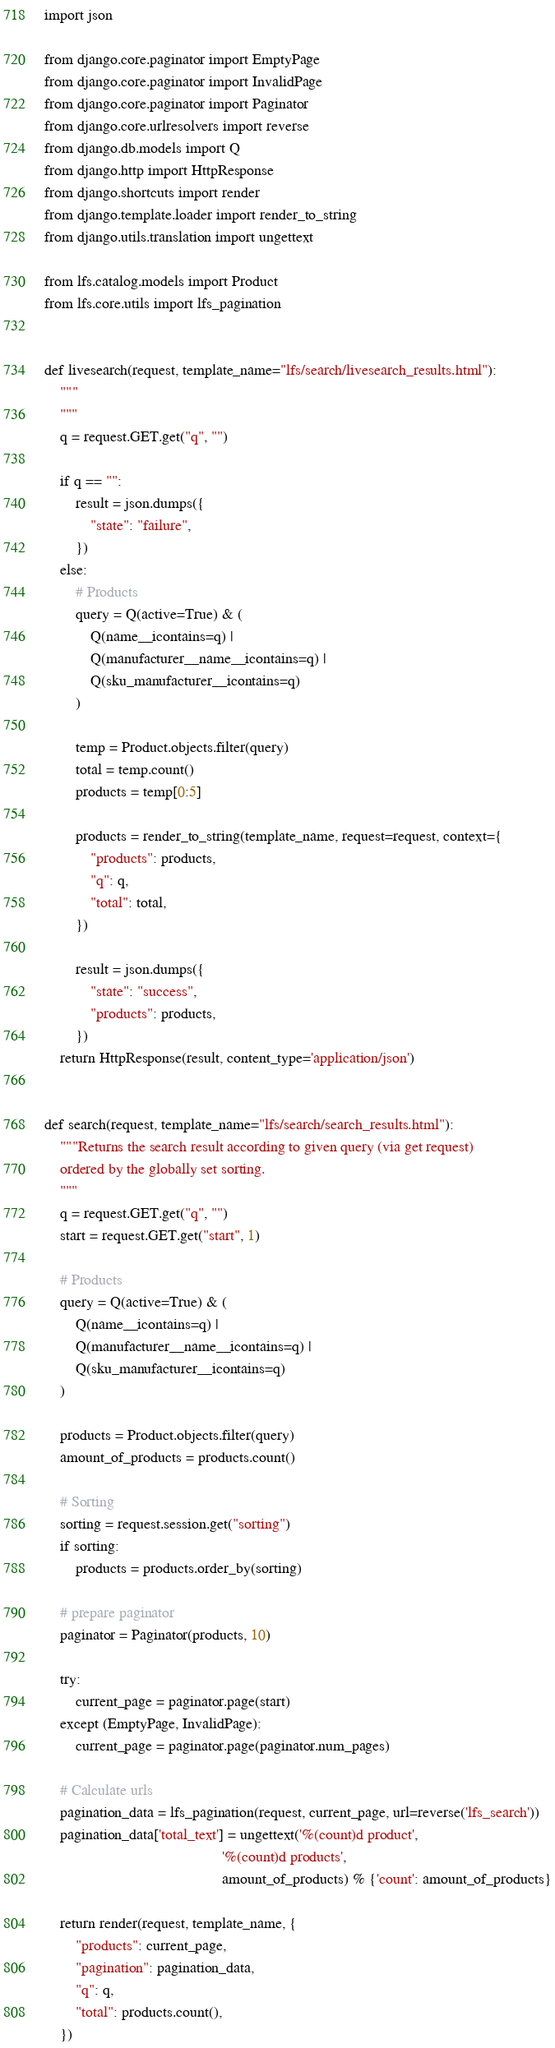Convert code to text. <code><loc_0><loc_0><loc_500><loc_500><_Python_>import json

from django.core.paginator import EmptyPage
from django.core.paginator import InvalidPage
from django.core.paginator import Paginator
from django.core.urlresolvers import reverse
from django.db.models import Q
from django.http import HttpResponse
from django.shortcuts import render
from django.template.loader import render_to_string
from django.utils.translation import ungettext

from lfs.catalog.models import Product
from lfs.core.utils import lfs_pagination


def livesearch(request, template_name="lfs/search/livesearch_results.html"):
    """
    """
    q = request.GET.get("q", "")

    if q == "":
        result = json.dumps({
            "state": "failure",
        })
    else:
        # Products
        query = Q(active=True) & (
            Q(name__icontains=q) |
            Q(manufacturer__name__icontains=q) |
            Q(sku_manufacturer__icontains=q)
        )

        temp = Product.objects.filter(query)
        total = temp.count()
        products = temp[0:5]

        products = render_to_string(template_name, request=request, context={
            "products": products,
            "q": q,
            "total": total,
        })

        result = json.dumps({
            "state": "success",
            "products": products,
        })
    return HttpResponse(result, content_type='application/json')


def search(request, template_name="lfs/search/search_results.html"):
    """Returns the search result according to given query (via get request)
    ordered by the globally set sorting.
    """
    q = request.GET.get("q", "")
    start = request.GET.get("start", 1)

    # Products
    query = Q(active=True) & (
        Q(name__icontains=q) |
        Q(manufacturer__name__icontains=q) |
        Q(sku_manufacturer__icontains=q)
    )

    products = Product.objects.filter(query)
    amount_of_products = products.count()

    # Sorting
    sorting = request.session.get("sorting")
    if sorting:
        products = products.order_by(sorting)

    # prepare paginator
    paginator = Paginator(products, 10)

    try:
        current_page = paginator.page(start)
    except (EmptyPage, InvalidPage):
        current_page = paginator.page(paginator.num_pages)

    # Calculate urls
    pagination_data = lfs_pagination(request, current_page, url=reverse('lfs_search'))
    pagination_data['total_text'] = ungettext('%(count)d product',
                                              '%(count)d products',
                                              amount_of_products) % {'count': amount_of_products}

    return render(request, template_name, {
        "products": current_page,
        "pagination": pagination_data,
        "q": q,
        "total": products.count(),
    })
</code> 